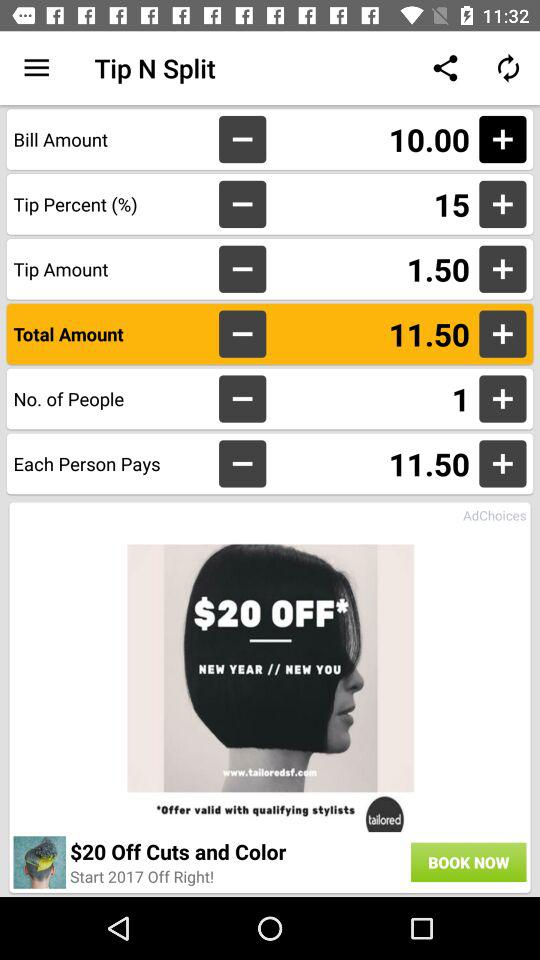What is the tip amount? The tip amount is 1.50. 